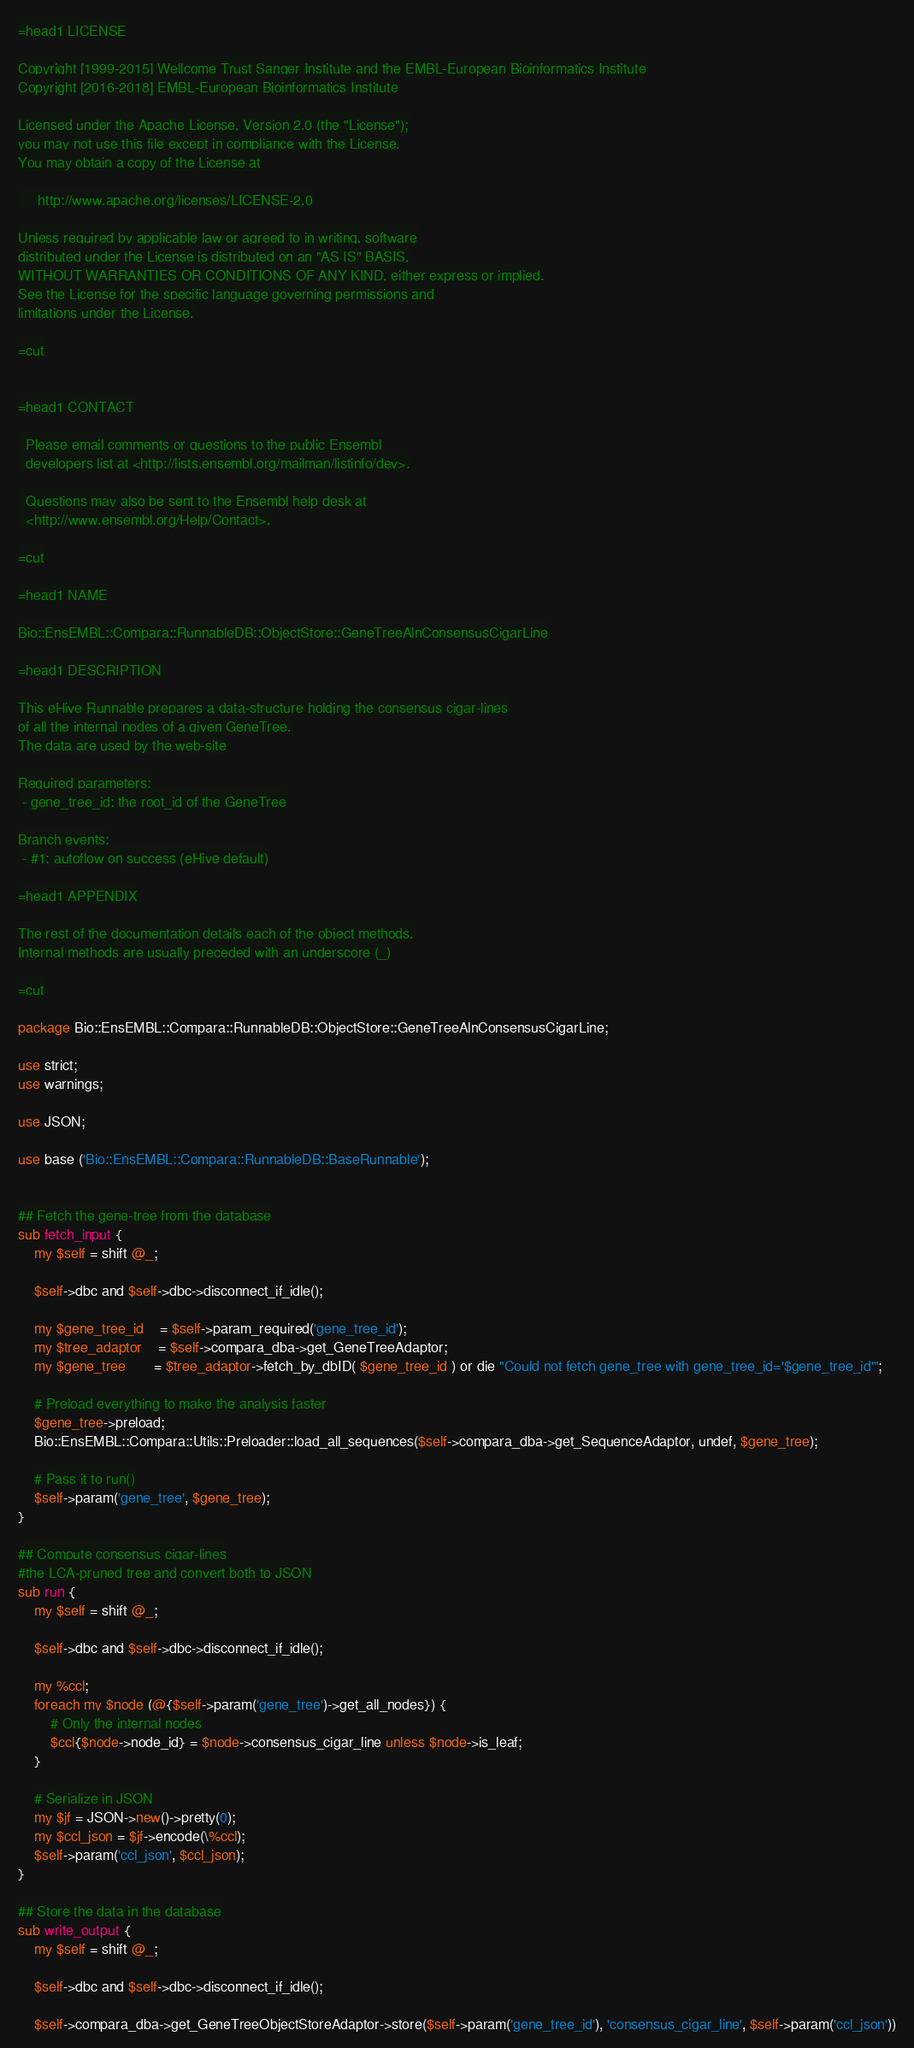Convert code to text. <code><loc_0><loc_0><loc_500><loc_500><_Perl_>=head1 LICENSE

Copyright [1999-2015] Wellcome Trust Sanger Institute and the EMBL-European Bioinformatics Institute
Copyright [2016-2018] EMBL-European Bioinformatics Institute

Licensed under the Apache License, Version 2.0 (the "License");
you may not use this file except in compliance with the License.
You may obtain a copy of the License at

     http://www.apache.org/licenses/LICENSE-2.0

Unless required by applicable law or agreed to in writing, software
distributed under the License is distributed on an "AS IS" BASIS,
WITHOUT WARRANTIES OR CONDITIONS OF ANY KIND, either express or implied.
See the License for the specific language governing permissions and
limitations under the License.

=cut


=head1 CONTACT

  Please email comments or questions to the public Ensembl
  developers list at <http://lists.ensembl.org/mailman/listinfo/dev>.

  Questions may also be sent to the Ensembl help desk at
  <http://www.ensembl.org/Help/Contact>.

=cut

=head1 NAME

Bio::EnsEMBL::Compara::RunnableDB::ObjectStore::GeneTreeAlnConsensusCigarLine

=head1 DESCRIPTION

This eHive Runnable prepares a data-structure holding the consensus cigar-lines
of all the internal nodes of a given GeneTree.
The data are used by the web-site

Required parameters:
 - gene_tree_id: the root_id of the GeneTree

Branch events:
 - #1: autoflow on success (eHive default)

=head1 APPENDIX

The rest of the documentation details each of the object methods.
Internal methods are usually preceded with an underscore (_)

=cut

package Bio::EnsEMBL::Compara::RunnableDB::ObjectStore::GeneTreeAlnConsensusCigarLine;

use strict;
use warnings;

use JSON;

use base ('Bio::EnsEMBL::Compara::RunnableDB::BaseRunnable');


## Fetch the gene-tree from the database
sub fetch_input {
    my $self = shift @_;

    $self->dbc and $self->dbc->disconnect_if_idle();

    my $gene_tree_id    = $self->param_required('gene_tree_id');
    my $tree_adaptor    = $self->compara_dba->get_GeneTreeAdaptor;
    my $gene_tree       = $tree_adaptor->fetch_by_dbID( $gene_tree_id ) or die "Could not fetch gene_tree with gene_tree_id='$gene_tree_id'";

    # Preload everything to make the analysis faster
    $gene_tree->preload;
    Bio::EnsEMBL::Compara::Utils::Preloader::load_all_sequences($self->compara_dba->get_SequenceAdaptor, undef, $gene_tree);

    # Pass it to run()
    $self->param('gene_tree', $gene_tree);
}

## Compute consensus cigar-lines
#the LCA-pruned tree and convert both to JSON
sub run {
    my $self = shift @_;

    $self->dbc and $self->dbc->disconnect_if_idle();

    my %ccl;
    foreach my $node (@{$self->param('gene_tree')->get_all_nodes}) {
        # Only the internal nodes
        $ccl{$node->node_id} = $node->consensus_cigar_line unless $node->is_leaf;
    }

    # Serialize in JSON
    my $jf = JSON->new()->pretty(0);
    my $ccl_json = $jf->encode(\%ccl);
    $self->param('ccl_json', $ccl_json);
}

## Store the data in the database
sub write_output {
    my $self = shift @_;

    $self->dbc and $self->dbc->disconnect_if_idle();

    $self->compara_dba->get_GeneTreeObjectStoreAdaptor->store($self->param('gene_tree_id'), 'consensus_cigar_line', $self->param('ccl_json'))</code> 